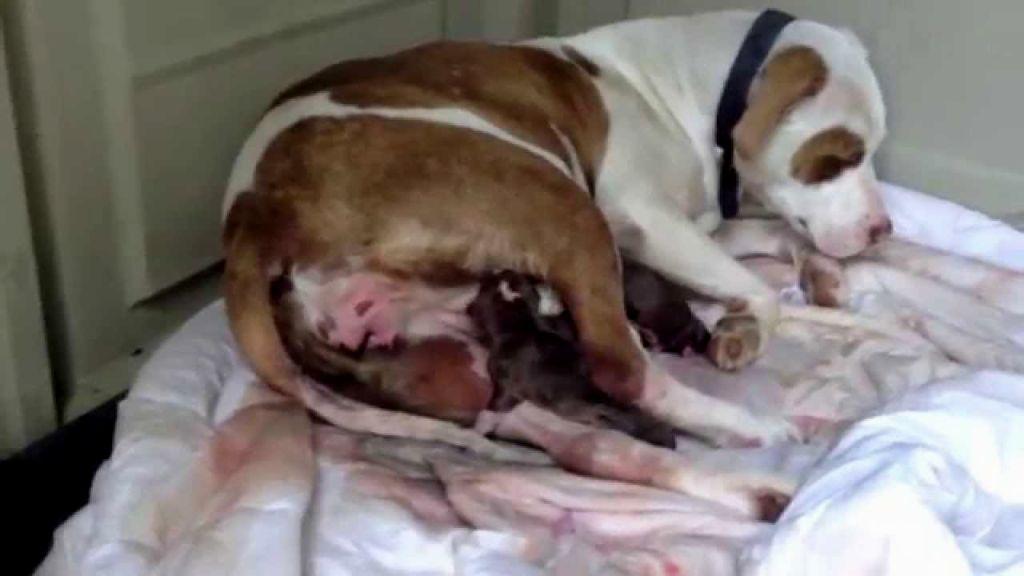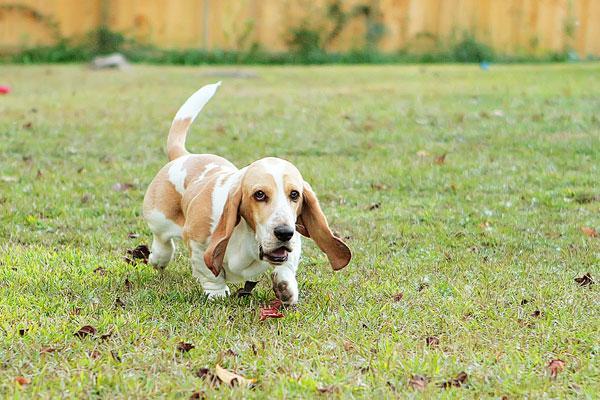The first image is the image on the left, the second image is the image on the right. Evaluate the accuracy of this statement regarding the images: "There is at least one pug and one baby.". Is it true? Answer yes or no. No. The first image is the image on the left, the second image is the image on the right. Considering the images on both sides, is "In the right image, there's a single basset hound running through the grass." valid? Answer yes or no. Yes. 